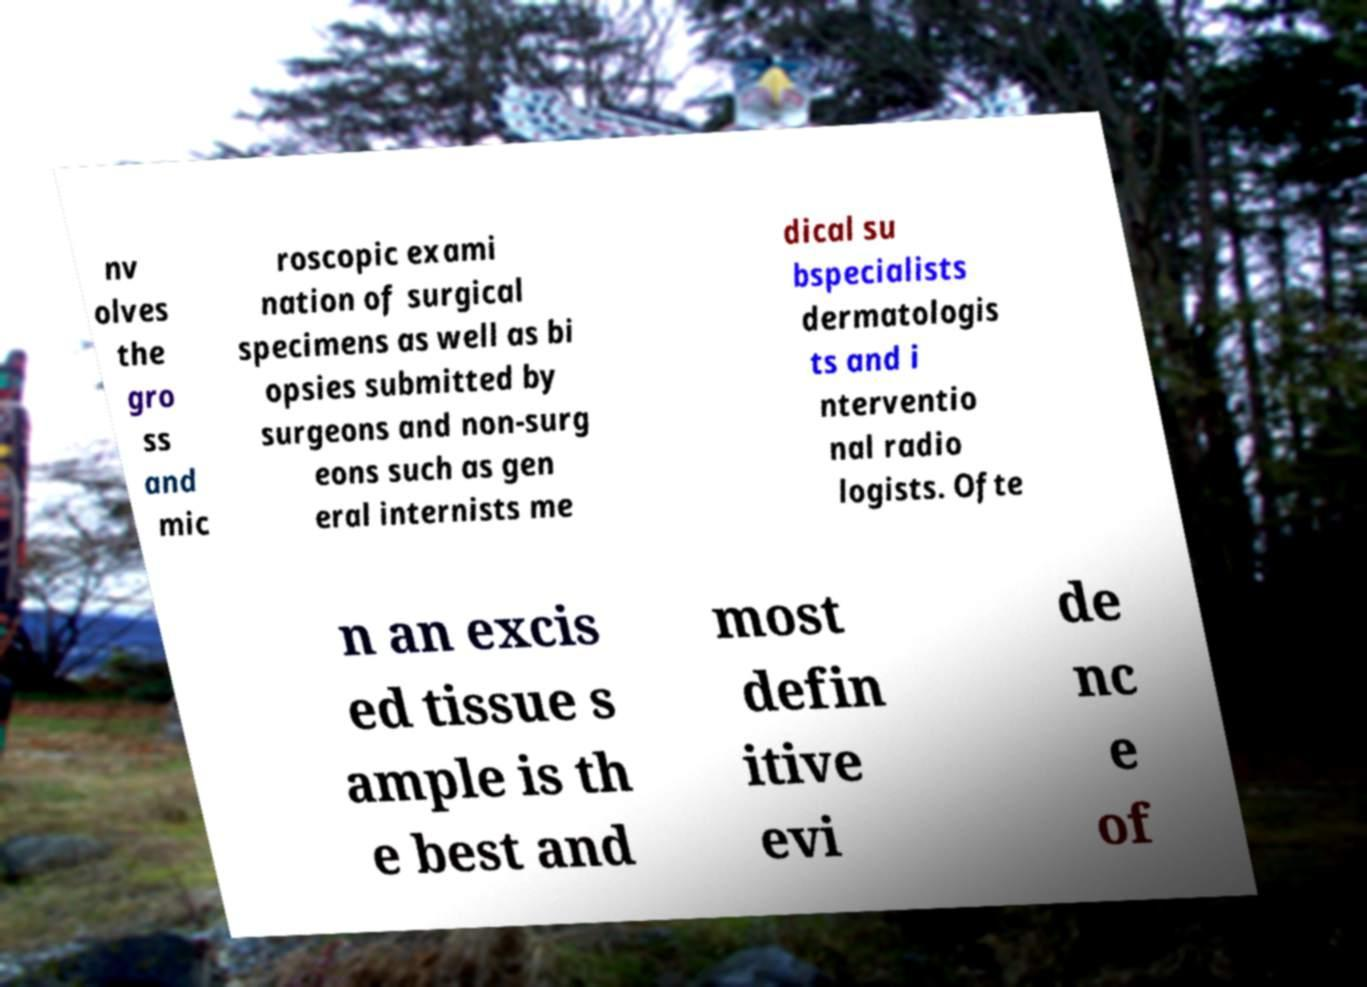Can you accurately transcribe the text from the provided image for me? nv olves the gro ss and mic roscopic exami nation of surgical specimens as well as bi opsies submitted by surgeons and non-surg eons such as gen eral internists me dical su bspecialists dermatologis ts and i nterventio nal radio logists. Ofte n an excis ed tissue s ample is th e best and most defin itive evi de nc e of 